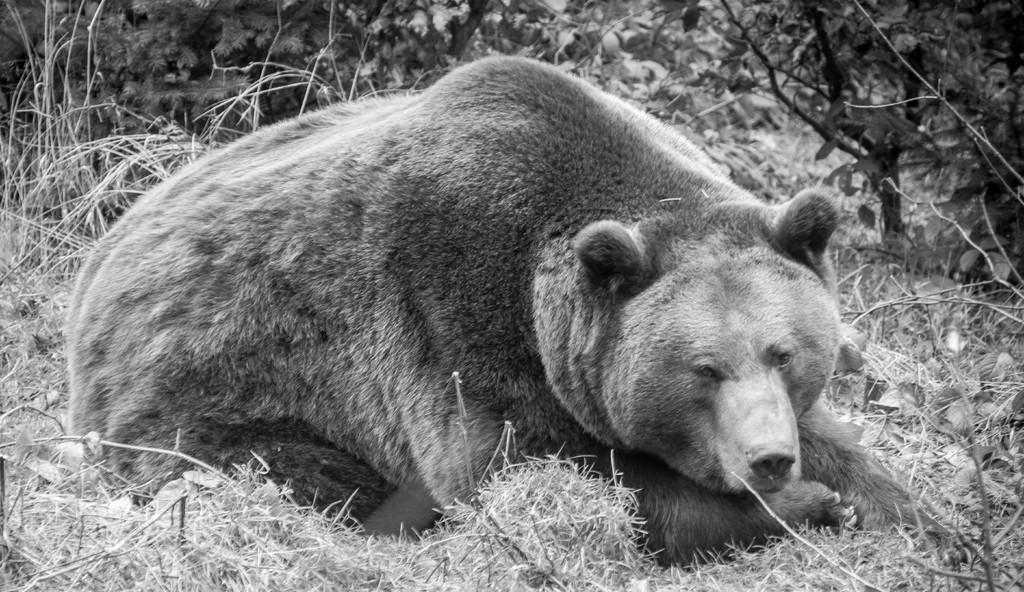What is the color scheme of the image? The image is black and white. What can be seen in the image besides the color scheme? There is an animal in the image. What is the animal doing in the image? The animal is sitting on the grass. What can be seen in the background of the image? There are trees in the background of the image. What type of learning is the animal engaged in while sitting on the grass? There is no indication in the image that the animal is engaged in any learning activities. 